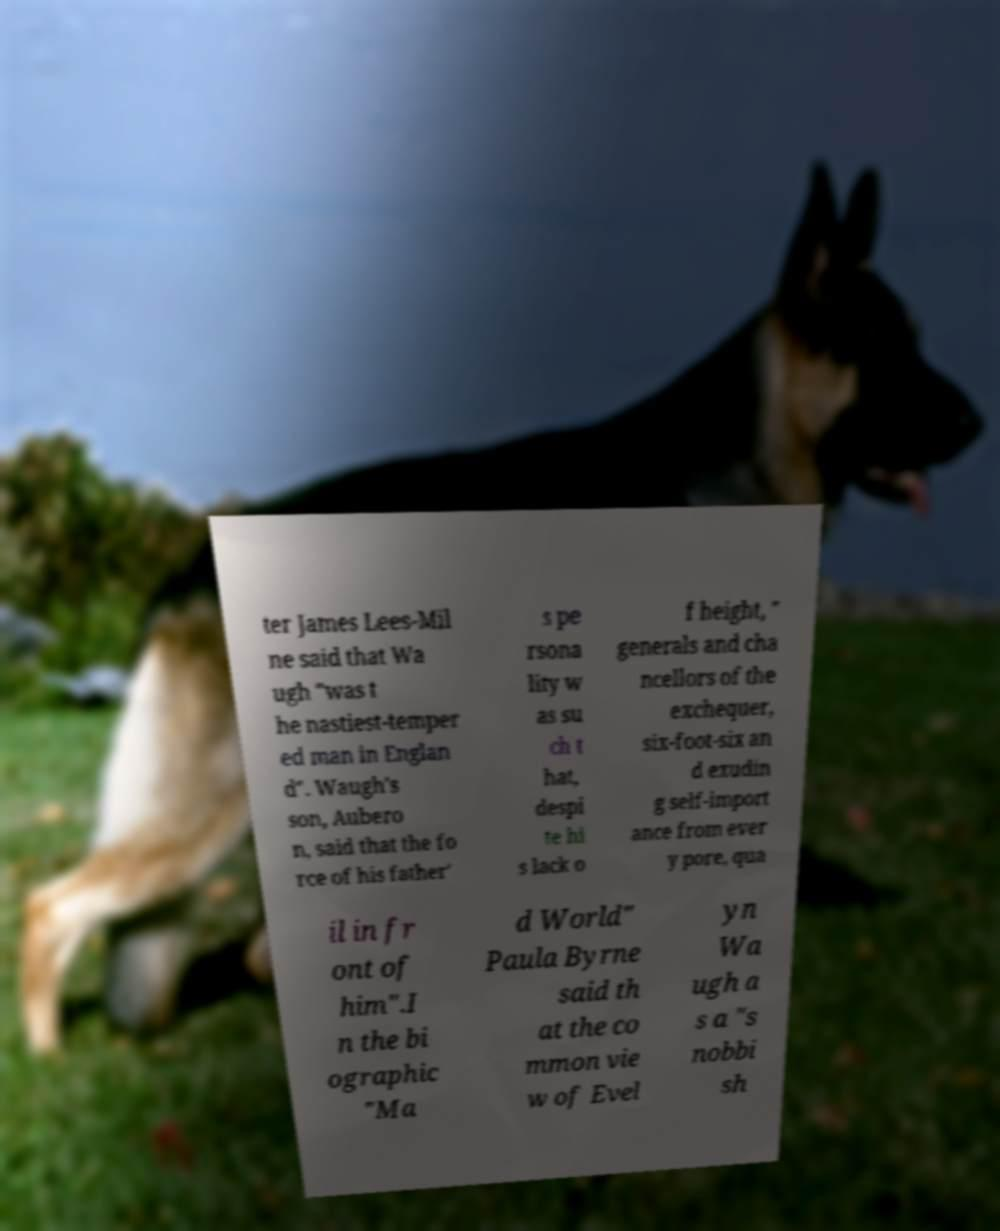I need the written content from this picture converted into text. Can you do that? ter James Lees-Mil ne said that Wa ugh "was t he nastiest-temper ed man in Englan d". Waugh's son, Aubero n, said that the fo rce of his father' s pe rsona lity w as su ch t hat, despi te hi s lack o f height, " generals and cha ncellors of the exchequer, six-foot-six an d exudin g self-import ance from ever y pore, qua il in fr ont of him".I n the bi ographic "Ma d World" Paula Byrne said th at the co mmon vie w of Evel yn Wa ugh a s a "s nobbi sh 